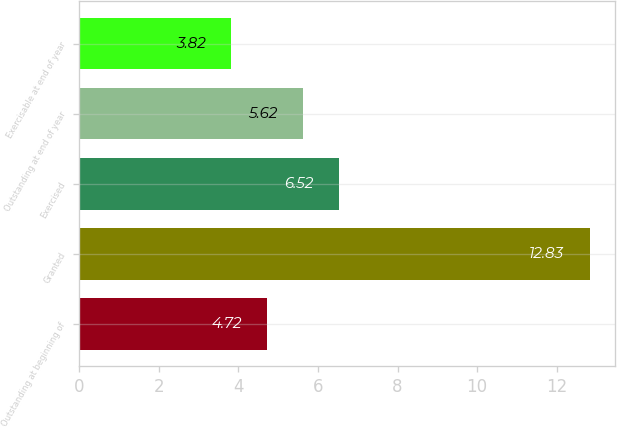Convert chart to OTSL. <chart><loc_0><loc_0><loc_500><loc_500><bar_chart><fcel>Outstanding at beginning of<fcel>Granted<fcel>Exercised<fcel>Outstanding at end of year<fcel>Exercisable at end of year<nl><fcel>4.72<fcel>12.83<fcel>6.52<fcel>5.62<fcel>3.82<nl></chart> 